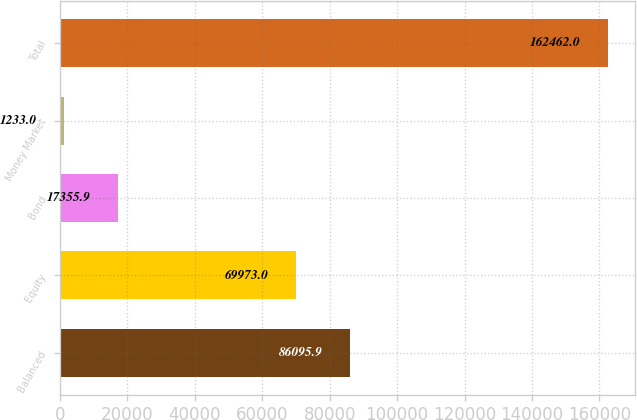Convert chart to OTSL. <chart><loc_0><loc_0><loc_500><loc_500><bar_chart><fcel>Balanced<fcel>Equity<fcel>Bond<fcel>Money Market<fcel>Total<nl><fcel>86095.9<fcel>69973<fcel>17355.9<fcel>1233<fcel>162462<nl></chart> 